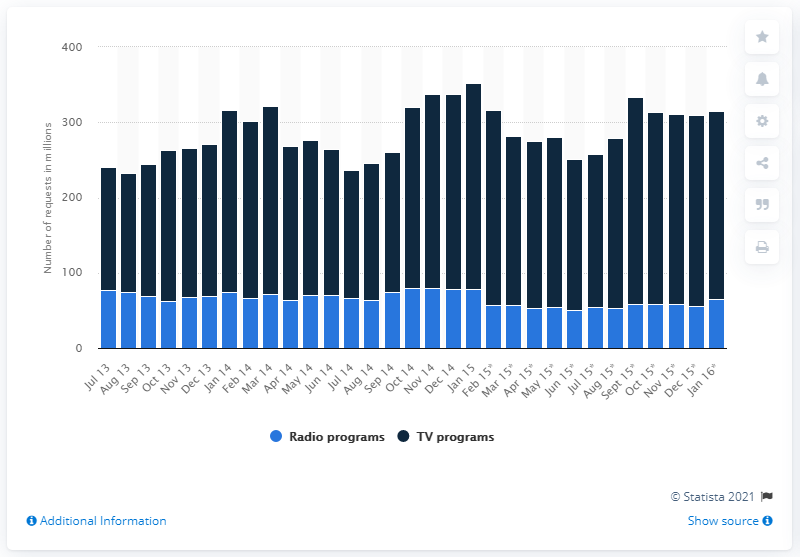Highlight a few significant elements in this photo. In May 2015, there were 226 requests for television programs. In January 2016, approximately 250 requests were made for BBC iPlayer. 